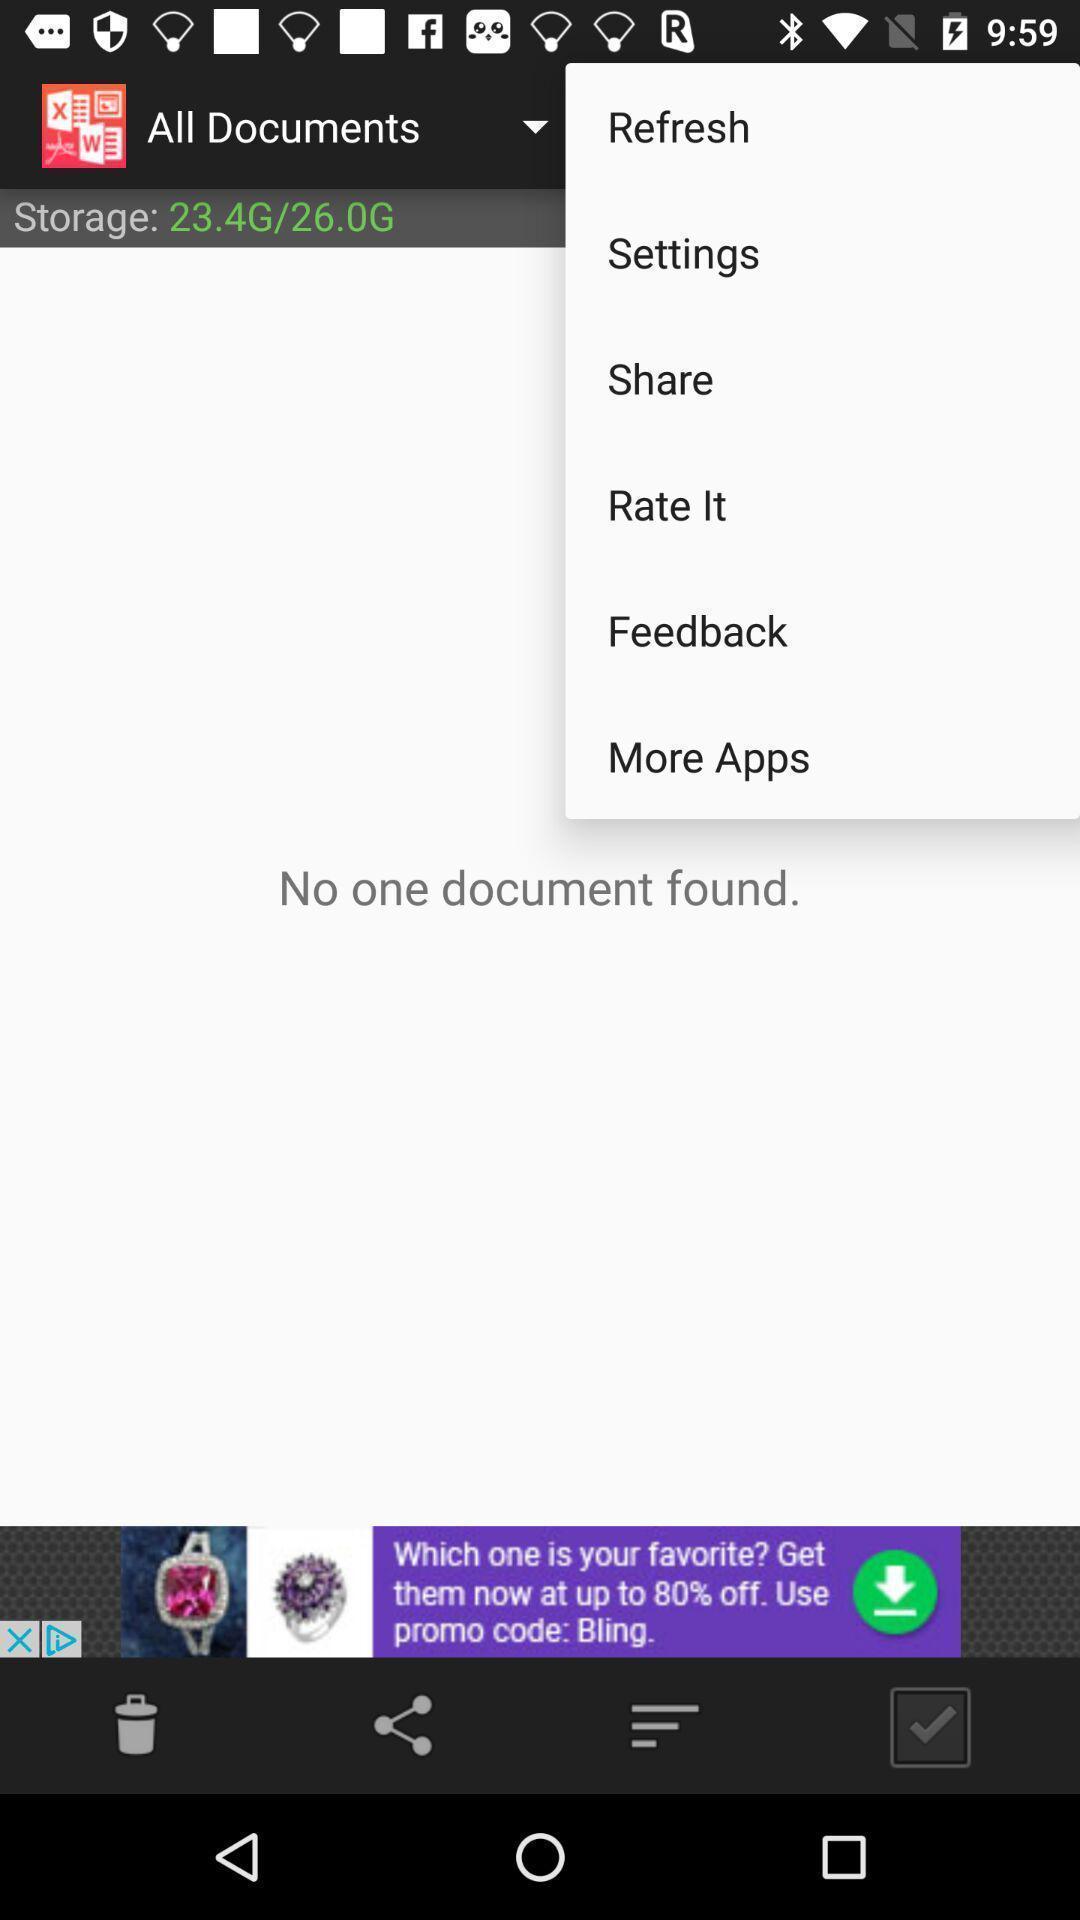Describe this image in words. Page displaying storage of documents. 